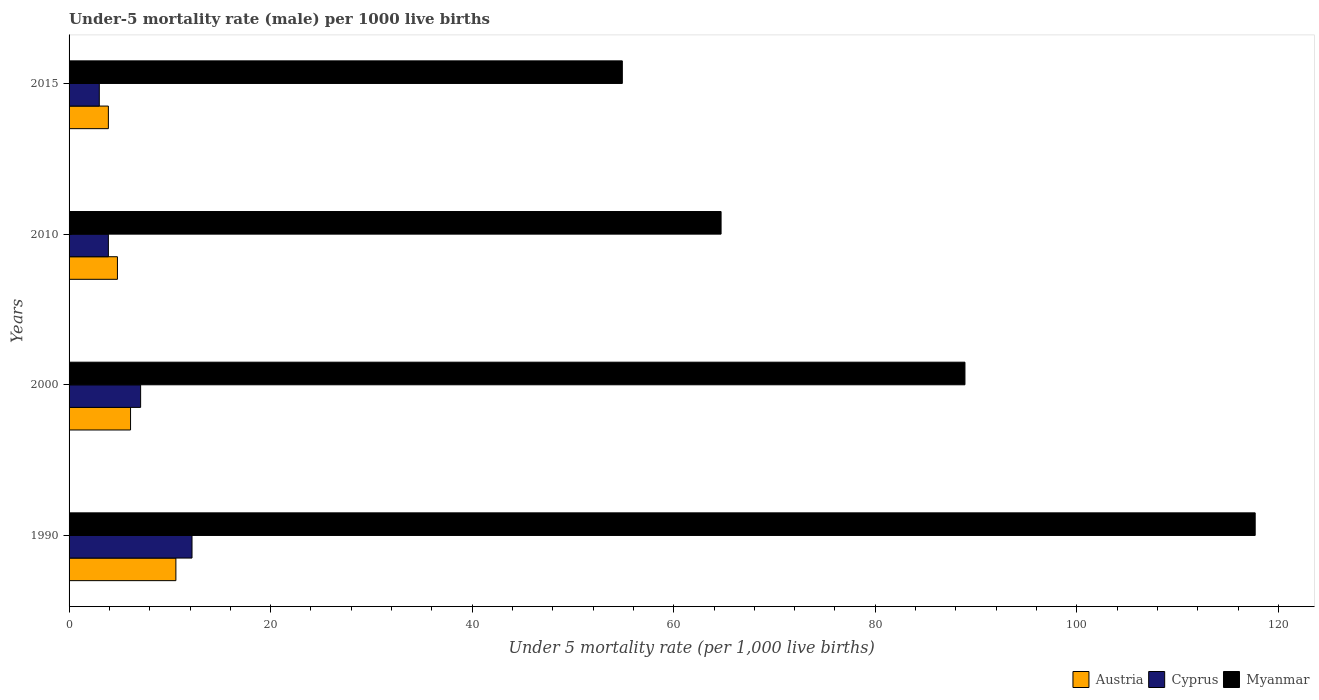How many different coloured bars are there?
Ensure brevity in your answer.  3. How many groups of bars are there?
Provide a short and direct response. 4. Are the number of bars per tick equal to the number of legend labels?
Provide a succinct answer. Yes. How many bars are there on the 4th tick from the top?
Your response must be concise. 3. How many bars are there on the 3rd tick from the bottom?
Make the answer very short. 3. In how many cases, is the number of bars for a given year not equal to the number of legend labels?
Give a very brief answer. 0. Across all years, what is the minimum under-five mortality rate in Myanmar?
Offer a terse response. 54.9. In which year was the under-five mortality rate in Austria maximum?
Make the answer very short. 1990. In which year was the under-five mortality rate in Cyprus minimum?
Give a very brief answer. 2015. What is the total under-five mortality rate in Cyprus in the graph?
Your response must be concise. 26.2. What is the difference between the under-five mortality rate in Myanmar in 1990 and that in 2000?
Make the answer very short. 28.8. What is the difference between the under-five mortality rate in Austria in 2000 and the under-five mortality rate in Myanmar in 2015?
Your response must be concise. -48.8. What is the average under-five mortality rate in Myanmar per year?
Make the answer very short. 81.55. In the year 2000, what is the difference between the under-five mortality rate in Cyprus and under-five mortality rate in Austria?
Give a very brief answer. 1. In how many years, is the under-five mortality rate in Austria greater than 116 ?
Make the answer very short. 0. What is the ratio of the under-five mortality rate in Myanmar in 2000 to that in 2010?
Your answer should be compact. 1.37. What is the difference between the highest and the second highest under-five mortality rate in Myanmar?
Keep it short and to the point. 28.8. In how many years, is the under-five mortality rate in Austria greater than the average under-five mortality rate in Austria taken over all years?
Your response must be concise. 1. What does the 1st bar from the top in 1990 represents?
Provide a short and direct response. Myanmar. What does the 2nd bar from the bottom in 2010 represents?
Provide a short and direct response. Cyprus. Where does the legend appear in the graph?
Ensure brevity in your answer.  Bottom right. How many legend labels are there?
Your answer should be compact. 3. How are the legend labels stacked?
Offer a very short reply. Horizontal. What is the title of the graph?
Provide a succinct answer. Under-5 mortality rate (male) per 1000 live births. What is the label or title of the X-axis?
Your response must be concise. Under 5 mortality rate (per 1,0 live births). What is the Under 5 mortality rate (per 1,000 live births) of Austria in 1990?
Keep it short and to the point. 10.6. What is the Under 5 mortality rate (per 1,000 live births) in Myanmar in 1990?
Make the answer very short. 117.7. What is the Under 5 mortality rate (per 1,000 live births) of Cyprus in 2000?
Your answer should be compact. 7.1. What is the Under 5 mortality rate (per 1,000 live births) in Myanmar in 2000?
Offer a terse response. 88.9. What is the Under 5 mortality rate (per 1,000 live births) of Myanmar in 2010?
Offer a very short reply. 64.7. What is the Under 5 mortality rate (per 1,000 live births) in Austria in 2015?
Keep it short and to the point. 3.9. What is the Under 5 mortality rate (per 1,000 live births) of Myanmar in 2015?
Offer a very short reply. 54.9. Across all years, what is the maximum Under 5 mortality rate (per 1,000 live births) of Austria?
Offer a terse response. 10.6. Across all years, what is the maximum Under 5 mortality rate (per 1,000 live births) of Cyprus?
Give a very brief answer. 12.2. Across all years, what is the maximum Under 5 mortality rate (per 1,000 live births) of Myanmar?
Give a very brief answer. 117.7. Across all years, what is the minimum Under 5 mortality rate (per 1,000 live births) in Myanmar?
Offer a terse response. 54.9. What is the total Under 5 mortality rate (per 1,000 live births) in Austria in the graph?
Offer a very short reply. 25.4. What is the total Under 5 mortality rate (per 1,000 live births) in Cyprus in the graph?
Your response must be concise. 26.2. What is the total Under 5 mortality rate (per 1,000 live births) of Myanmar in the graph?
Provide a short and direct response. 326.2. What is the difference between the Under 5 mortality rate (per 1,000 live births) of Cyprus in 1990 and that in 2000?
Provide a succinct answer. 5.1. What is the difference between the Under 5 mortality rate (per 1,000 live births) in Myanmar in 1990 and that in 2000?
Your response must be concise. 28.8. What is the difference between the Under 5 mortality rate (per 1,000 live births) of Cyprus in 1990 and that in 2015?
Offer a very short reply. 9.2. What is the difference between the Under 5 mortality rate (per 1,000 live births) of Myanmar in 1990 and that in 2015?
Keep it short and to the point. 62.8. What is the difference between the Under 5 mortality rate (per 1,000 live births) in Myanmar in 2000 and that in 2010?
Offer a very short reply. 24.2. What is the difference between the Under 5 mortality rate (per 1,000 live births) in Cyprus in 2000 and that in 2015?
Ensure brevity in your answer.  4.1. What is the difference between the Under 5 mortality rate (per 1,000 live births) in Austria in 2010 and that in 2015?
Your response must be concise. 0.9. What is the difference between the Under 5 mortality rate (per 1,000 live births) of Myanmar in 2010 and that in 2015?
Your answer should be very brief. 9.8. What is the difference between the Under 5 mortality rate (per 1,000 live births) in Austria in 1990 and the Under 5 mortality rate (per 1,000 live births) in Cyprus in 2000?
Offer a terse response. 3.5. What is the difference between the Under 5 mortality rate (per 1,000 live births) in Austria in 1990 and the Under 5 mortality rate (per 1,000 live births) in Myanmar in 2000?
Offer a terse response. -78.3. What is the difference between the Under 5 mortality rate (per 1,000 live births) in Cyprus in 1990 and the Under 5 mortality rate (per 1,000 live births) in Myanmar in 2000?
Offer a terse response. -76.7. What is the difference between the Under 5 mortality rate (per 1,000 live births) of Austria in 1990 and the Under 5 mortality rate (per 1,000 live births) of Myanmar in 2010?
Make the answer very short. -54.1. What is the difference between the Under 5 mortality rate (per 1,000 live births) in Cyprus in 1990 and the Under 5 mortality rate (per 1,000 live births) in Myanmar in 2010?
Offer a very short reply. -52.5. What is the difference between the Under 5 mortality rate (per 1,000 live births) of Austria in 1990 and the Under 5 mortality rate (per 1,000 live births) of Cyprus in 2015?
Your answer should be very brief. 7.6. What is the difference between the Under 5 mortality rate (per 1,000 live births) in Austria in 1990 and the Under 5 mortality rate (per 1,000 live births) in Myanmar in 2015?
Offer a terse response. -44.3. What is the difference between the Under 5 mortality rate (per 1,000 live births) in Cyprus in 1990 and the Under 5 mortality rate (per 1,000 live births) in Myanmar in 2015?
Give a very brief answer. -42.7. What is the difference between the Under 5 mortality rate (per 1,000 live births) of Austria in 2000 and the Under 5 mortality rate (per 1,000 live births) of Myanmar in 2010?
Provide a succinct answer. -58.6. What is the difference between the Under 5 mortality rate (per 1,000 live births) in Cyprus in 2000 and the Under 5 mortality rate (per 1,000 live births) in Myanmar in 2010?
Give a very brief answer. -57.6. What is the difference between the Under 5 mortality rate (per 1,000 live births) of Austria in 2000 and the Under 5 mortality rate (per 1,000 live births) of Cyprus in 2015?
Make the answer very short. 3.1. What is the difference between the Under 5 mortality rate (per 1,000 live births) of Austria in 2000 and the Under 5 mortality rate (per 1,000 live births) of Myanmar in 2015?
Your answer should be compact. -48.8. What is the difference between the Under 5 mortality rate (per 1,000 live births) of Cyprus in 2000 and the Under 5 mortality rate (per 1,000 live births) of Myanmar in 2015?
Offer a terse response. -47.8. What is the difference between the Under 5 mortality rate (per 1,000 live births) in Austria in 2010 and the Under 5 mortality rate (per 1,000 live births) in Myanmar in 2015?
Offer a terse response. -50.1. What is the difference between the Under 5 mortality rate (per 1,000 live births) of Cyprus in 2010 and the Under 5 mortality rate (per 1,000 live births) of Myanmar in 2015?
Keep it short and to the point. -51. What is the average Under 5 mortality rate (per 1,000 live births) of Austria per year?
Your answer should be very brief. 6.35. What is the average Under 5 mortality rate (per 1,000 live births) of Cyprus per year?
Your answer should be very brief. 6.55. What is the average Under 5 mortality rate (per 1,000 live births) of Myanmar per year?
Provide a succinct answer. 81.55. In the year 1990, what is the difference between the Under 5 mortality rate (per 1,000 live births) of Austria and Under 5 mortality rate (per 1,000 live births) of Cyprus?
Your answer should be compact. -1.6. In the year 1990, what is the difference between the Under 5 mortality rate (per 1,000 live births) of Austria and Under 5 mortality rate (per 1,000 live births) of Myanmar?
Provide a short and direct response. -107.1. In the year 1990, what is the difference between the Under 5 mortality rate (per 1,000 live births) of Cyprus and Under 5 mortality rate (per 1,000 live births) of Myanmar?
Make the answer very short. -105.5. In the year 2000, what is the difference between the Under 5 mortality rate (per 1,000 live births) of Austria and Under 5 mortality rate (per 1,000 live births) of Myanmar?
Your answer should be very brief. -82.8. In the year 2000, what is the difference between the Under 5 mortality rate (per 1,000 live births) of Cyprus and Under 5 mortality rate (per 1,000 live births) of Myanmar?
Provide a short and direct response. -81.8. In the year 2010, what is the difference between the Under 5 mortality rate (per 1,000 live births) of Austria and Under 5 mortality rate (per 1,000 live births) of Myanmar?
Keep it short and to the point. -59.9. In the year 2010, what is the difference between the Under 5 mortality rate (per 1,000 live births) in Cyprus and Under 5 mortality rate (per 1,000 live births) in Myanmar?
Provide a succinct answer. -60.8. In the year 2015, what is the difference between the Under 5 mortality rate (per 1,000 live births) in Austria and Under 5 mortality rate (per 1,000 live births) in Cyprus?
Your answer should be compact. 0.9. In the year 2015, what is the difference between the Under 5 mortality rate (per 1,000 live births) in Austria and Under 5 mortality rate (per 1,000 live births) in Myanmar?
Your response must be concise. -51. In the year 2015, what is the difference between the Under 5 mortality rate (per 1,000 live births) of Cyprus and Under 5 mortality rate (per 1,000 live births) of Myanmar?
Give a very brief answer. -51.9. What is the ratio of the Under 5 mortality rate (per 1,000 live births) of Austria in 1990 to that in 2000?
Your answer should be compact. 1.74. What is the ratio of the Under 5 mortality rate (per 1,000 live births) in Cyprus in 1990 to that in 2000?
Give a very brief answer. 1.72. What is the ratio of the Under 5 mortality rate (per 1,000 live births) in Myanmar in 1990 to that in 2000?
Make the answer very short. 1.32. What is the ratio of the Under 5 mortality rate (per 1,000 live births) in Austria in 1990 to that in 2010?
Give a very brief answer. 2.21. What is the ratio of the Under 5 mortality rate (per 1,000 live births) of Cyprus in 1990 to that in 2010?
Make the answer very short. 3.13. What is the ratio of the Under 5 mortality rate (per 1,000 live births) in Myanmar in 1990 to that in 2010?
Keep it short and to the point. 1.82. What is the ratio of the Under 5 mortality rate (per 1,000 live births) of Austria in 1990 to that in 2015?
Your answer should be very brief. 2.72. What is the ratio of the Under 5 mortality rate (per 1,000 live births) of Cyprus in 1990 to that in 2015?
Your answer should be compact. 4.07. What is the ratio of the Under 5 mortality rate (per 1,000 live births) of Myanmar in 1990 to that in 2015?
Ensure brevity in your answer.  2.14. What is the ratio of the Under 5 mortality rate (per 1,000 live births) in Austria in 2000 to that in 2010?
Keep it short and to the point. 1.27. What is the ratio of the Under 5 mortality rate (per 1,000 live births) in Cyprus in 2000 to that in 2010?
Offer a terse response. 1.82. What is the ratio of the Under 5 mortality rate (per 1,000 live births) of Myanmar in 2000 to that in 2010?
Ensure brevity in your answer.  1.37. What is the ratio of the Under 5 mortality rate (per 1,000 live births) in Austria in 2000 to that in 2015?
Give a very brief answer. 1.56. What is the ratio of the Under 5 mortality rate (per 1,000 live births) in Cyprus in 2000 to that in 2015?
Offer a very short reply. 2.37. What is the ratio of the Under 5 mortality rate (per 1,000 live births) in Myanmar in 2000 to that in 2015?
Offer a terse response. 1.62. What is the ratio of the Under 5 mortality rate (per 1,000 live births) of Austria in 2010 to that in 2015?
Offer a very short reply. 1.23. What is the ratio of the Under 5 mortality rate (per 1,000 live births) in Cyprus in 2010 to that in 2015?
Give a very brief answer. 1.3. What is the ratio of the Under 5 mortality rate (per 1,000 live births) in Myanmar in 2010 to that in 2015?
Offer a terse response. 1.18. What is the difference between the highest and the second highest Under 5 mortality rate (per 1,000 live births) in Austria?
Ensure brevity in your answer.  4.5. What is the difference between the highest and the second highest Under 5 mortality rate (per 1,000 live births) of Cyprus?
Your answer should be compact. 5.1. What is the difference between the highest and the second highest Under 5 mortality rate (per 1,000 live births) of Myanmar?
Give a very brief answer. 28.8. What is the difference between the highest and the lowest Under 5 mortality rate (per 1,000 live births) of Austria?
Keep it short and to the point. 6.7. What is the difference between the highest and the lowest Under 5 mortality rate (per 1,000 live births) of Cyprus?
Your response must be concise. 9.2. What is the difference between the highest and the lowest Under 5 mortality rate (per 1,000 live births) in Myanmar?
Offer a very short reply. 62.8. 